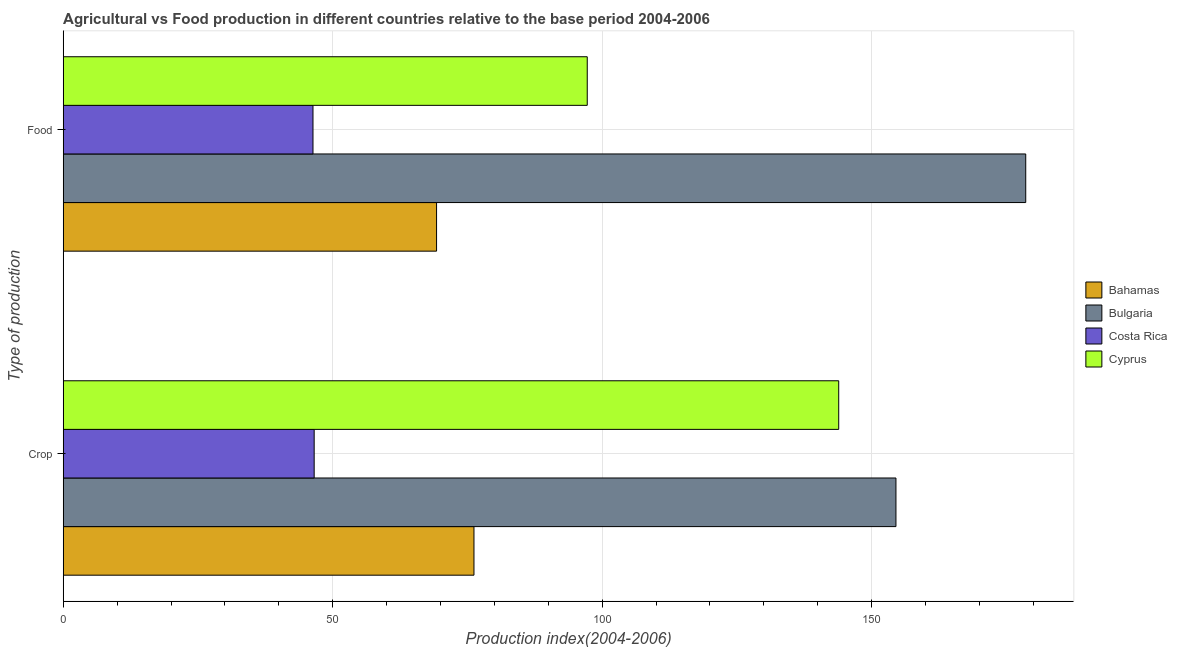Are the number of bars per tick equal to the number of legend labels?
Ensure brevity in your answer.  Yes. Are the number of bars on each tick of the Y-axis equal?
Give a very brief answer. Yes. What is the label of the 1st group of bars from the top?
Ensure brevity in your answer.  Food. What is the crop production index in Costa Rica?
Your response must be concise. 46.56. Across all countries, what is the maximum food production index?
Your answer should be very brief. 178.59. Across all countries, what is the minimum food production index?
Keep it short and to the point. 46.34. What is the total food production index in the graph?
Provide a short and direct response. 391.43. What is the difference between the food production index in Cyprus and that in Bahamas?
Your answer should be very brief. 27.96. What is the difference between the crop production index in Cyprus and the food production index in Costa Rica?
Your response must be concise. 97.55. What is the average crop production index per country?
Provide a succinct answer. 105.29. What is the difference between the crop production index and food production index in Bahamas?
Offer a very short reply. 6.94. In how many countries, is the food production index greater than 90 ?
Your answer should be compact. 2. What is the ratio of the crop production index in Costa Rica to that in Bulgaria?
Offer a very short reply. 0.3. In how many countries, is the crop production index greater than the average crop production index taken over all countries?
Offer a terse response. 2. What does the 1st bar from the top in Food represents?
Your answer should be very brief. Cyprus. How many bars are there?
Make the answer very short. 8. How many countries are there in the graph?
Your response must be concise. 4. What is the difference between two consecutive major ticks on the X-axis?
Offer a terse response. 50. Does the graph contain any zero values?
Offer a very short reply. No. Does the graph contain grids?
Ensure brevity in your answer.  Yes. Where does the legend appear in the graph?
Your answer should be very brief. Center right. How are the legend labels stacked?
Make the answer very short. Vertical. What is the title of the graph?
Your answer should be very brief. Agricultural vs Food production in different countries relative to the base period 2004-2006. Does "Syrian Arab Republic" appear as one of the legend labels in the graph?
Ensure brevity in your answer.  No. What is the label or title of the X-axis?
Keep it short and to the point. Production index(2004-2006). What is the label or title of the Y-axis?
Provide a succinct answer. Type of production. What is the Production index(2004-2006) of Bahamas in Crop?
Ensure brevity in your answer.  76.21. What is the Production index(2004-2006) of Bulgaria in Crop?
Offer a terse response. 154.51. What is the Production index(2004-2006) in Costa Rica in Crop?
Make the answer very short. 46.56. What is the Production index(2004-2006) of Cyprus in Crop?
Your answer should be compact. 143.89. What is the Production index(2004-2006) in Bahamas in Food?
Ensure brevity in your answer.  69.27. What is the Production index(2004-2006) in Bulgaria in Food?
Offer a terse response. 178.59. What is the Production index(2004-2006) in Costa Rica in Food?
Make the answer very short. 46.34. What is the Production index(2004-2006) in Cyprus in Food?
Give a very brief answer. 97.23. Across all Type of production, what is the maximum Production index(2004-2006) in Bahamas?
Offer a terse response. 76.21. Across all Type of production, what is the maximum Production index(2004-2006) in Bulgaria?
Provide a succinct answer. 178.59. Across all Type of production, what is the maximum Production index(2004-2006) in Costa Rica?
Offer a very short reply. 46.56. Across all Type of production, what is the maximum Production index(2004-2006) in Cyprus?
Your answer should be compact. 143.89. Across all Type of production, what is the minimum Production index(2004-2006) in Bahamas?
Offer a very short reply. 69.27. Across all Type of production, what is the minimum Production index(2004-2006) of Bulgaria?
Provide a short and direct response. 154.51. Across all Type of production, what is the minimum Production index(2004-2006) of Costa Rica?
Give a very brief answer. 46.34. Across all Type of production, what is the minimum Production index(2004-2006) of Cyprus?
Your answer should be very brief. 97.23. What is the total Production index(2004-2006) of Bahamas in the graph?
Keep it short and to the point. 145.48. What is the total Production index(2004-2006) of Bulgaria in the graph?
Your answer should be compact. 333.1. What is the total Production index(2004-2006) in Costa Rica in the graph?
Keep it short and to the point. 92.9. What is the total Production index(2004-2006) in Cyprus in the graph?
Make the answer very short. 241.12. What is the difference between the Production index(2004-2006) in Bahamas in Crop and that in Food?
Ensure brevity in your answer.  6.94. What is the difference between the Production index(2004-2006) in Bulgaria in Crop and that in Food?
Your answer should be very brief. -24.08. What is the difference between the Production index(2004-2006) in Costa Rica in Crop and that in Food?
Provide a short and direct response. 0.22. What is the difference between the Production index(2004-2006) in Cyprus in Crop and that in Food?
Keep it short and to the point. 46.66. What is the difference between the Production index(2004-2006) in Bahamas in Crop and the Production index(2004-2006) in Bulgaria in Food?
Offer a terse response. -102.38. What is the difference between the Production index(2004-2006) in Bahamas in Crop and the Production index(2004-2006) in Costa Rica in Food?
Keep it short and to the point. 29.87. What is the difference between the Production index(2004-2006) in Bahamas in Crop and the Production index(2004-2006) in Cyprus in Food?
Give a very brief answer. -21.02. What is the difference between the Production index(2004-2006) of Bulgaria in Crop and the Production index(2004-2006) of Costa Rica in Food?
Make the answer very short. 108.17. What is the difference between the Production index(2004-2006) in Bulgaria in Crop and the Production index(2004-2006) in Cyprus in Food?
Offer a terse response. 57.28. What is the difference between the Production index(2004-2006) of Costa Rica in Crop and the Production index(2004-2006) of Cyprus in Food?
Offer a terse response. -50.67. What is the average Production index(2004-2006) of Bahamas per Type of production?
Your answer should be very brief. 72.74. What is the average Production index(2004-2006) in Bulgaria per Type of production?
Provide a short and direct response. 166.55. What is the average Production index(2004-2006) of Costa Rica per Type of production?
Provide a succinct answer. 46.45. What is the average Production index(2004-2006) of Cyprus per Type of production?
Offer a very short reply. 120.56. What is the difference between the Production index(2004-2006) in Bahamas and Production index(2004-2006) in Bulgaria in Crop?
Your answer should be compact. -78.3. What is the difference between the Production index(2004-2006) in Bahamas and Production index(2004-2006) in Costa Rica in Crop?
Give a very brief answer. 29.65. What is the difference between the Production index(2004-2006) of Bahamas and Production index(2004-2006) of Cyprus in Crop?
Offer a very short reply. -67.68. What is the difference between the Production index(2004-2006) in Bulgaria and Production index(2004-2006) in Costa Rica in Crop?
Offer a very short reply. 107.95. What is the difference between the Production index(2004-2006) in Bulgaria and Production index(2004-2006) in Cyprus in Crop?
Provide a short and direct response. 10.62. What is the difference between the Production index(2004-2006) of Costa Rica and Production index(2004-2006) of Cyprus in Crop?
Ensure brevity in your answer.  -97.33. What is the difference between the Production index(2004-2006) in Bahamas and Production index(2004-2006) in Bulgaria in Food?
Give a very brief answer. -109.32. What is the difference between the Production index(2004-2006) in Bahamas and Production index(2004-2006) in Costa Rica in Food?
Give a very brief answer. 22.93. What is the difference between the Production index(2004-2006) in Bahamas and Production index(2004-2006) in Cyprus in Food?
Your answer should be very brief. -27.96. What is the difference between the Production index(2004-2006) of Bulgaria and Production index(2004-2006) of Costa Rica in Food?
Keep it short and to the point. 132.25. What is the difference between the Production index(2004-2006) of Bulgaria and Production index(2004-2006) of Cyprus in Food?
Keep it short and to the point. 81.36. What is the difference between the Production index(2004-2006) in Costa Rica and Production index(2004-2006) in Cyprus in Food?
Your answer should be compact. -50.89. What is the ratio of the Production index(2004-2006) of Bahamas in Crop to that in Food?
Give a very brief answer. 1.1. What is the ratio of the Production index(2004-2006) of Bulgaria in Crop to that in Food?
Offer a terse response. 0.87. What is the ratio of the Production index(2004-2006) of Cyprus in Crop to that in Food?
Provide a short and direct response. 1.48. What is the difference between the highest and the second highest Production index(2004-2006) in Bahamas?
Provide a short and direct response. 6.94. What is the difference between the highest and the second highest Production index(2004-2006) of Bulgaria?
Provide a succinct answer. 24.08. What is the difference between the highest and the second highest Production index(2004-2006) in Costa Rica?
Ensure brevity in your answer.  0.22. What is the difference between the highest and the second highest Production index(2004-2006) in Cyprus?
Keep it short and to the point. 46.66. What is the difference between the highest and the lowest Production index(2004-2006) of Bahamas?
Provide a succinct answer. 6.94. What is the difference between the highest and the lowest Production index(2004-2006) in Bulgaria?
Offer a very short reply. 24.08. What is the difference between the highest and the lowest Production index(2004-2006) in Costa Rica?
Make the answer very short. 0.22. What is the difference between the highest and the lowest Production index(2004-2006) of Cyprus?
Offer a very short reply. 46.66. 